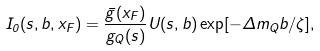Convert formula to latex. <formula><loc_0><loc_0><loc_500><loc_500>I _ { 0 } ( s , b , x _ { F } ) = \frac { \bar { g } ( x _ { F } ) } { g _ { Q } ( s ) } U ( s , b ) \exp [ - \Delta m _ { Q } b / \zeta ] ,</formula> 